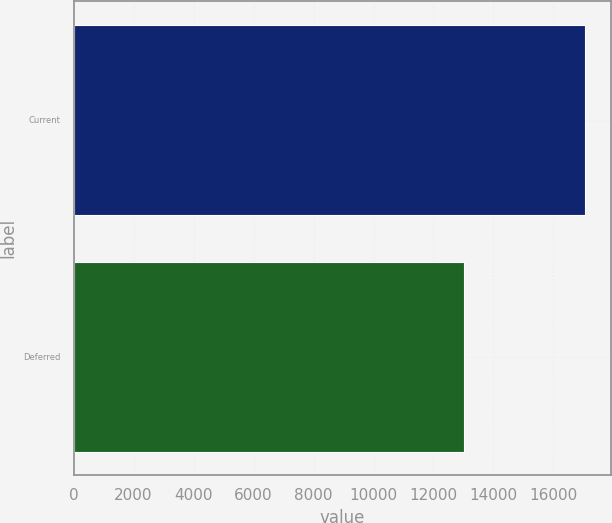<chart> <loc_0><loc_0><loc_500><loc_500><bar_chart><fcel>Current<fcel>Deferred<nl><fcel>17059<fcel>13027<nl></chart> 